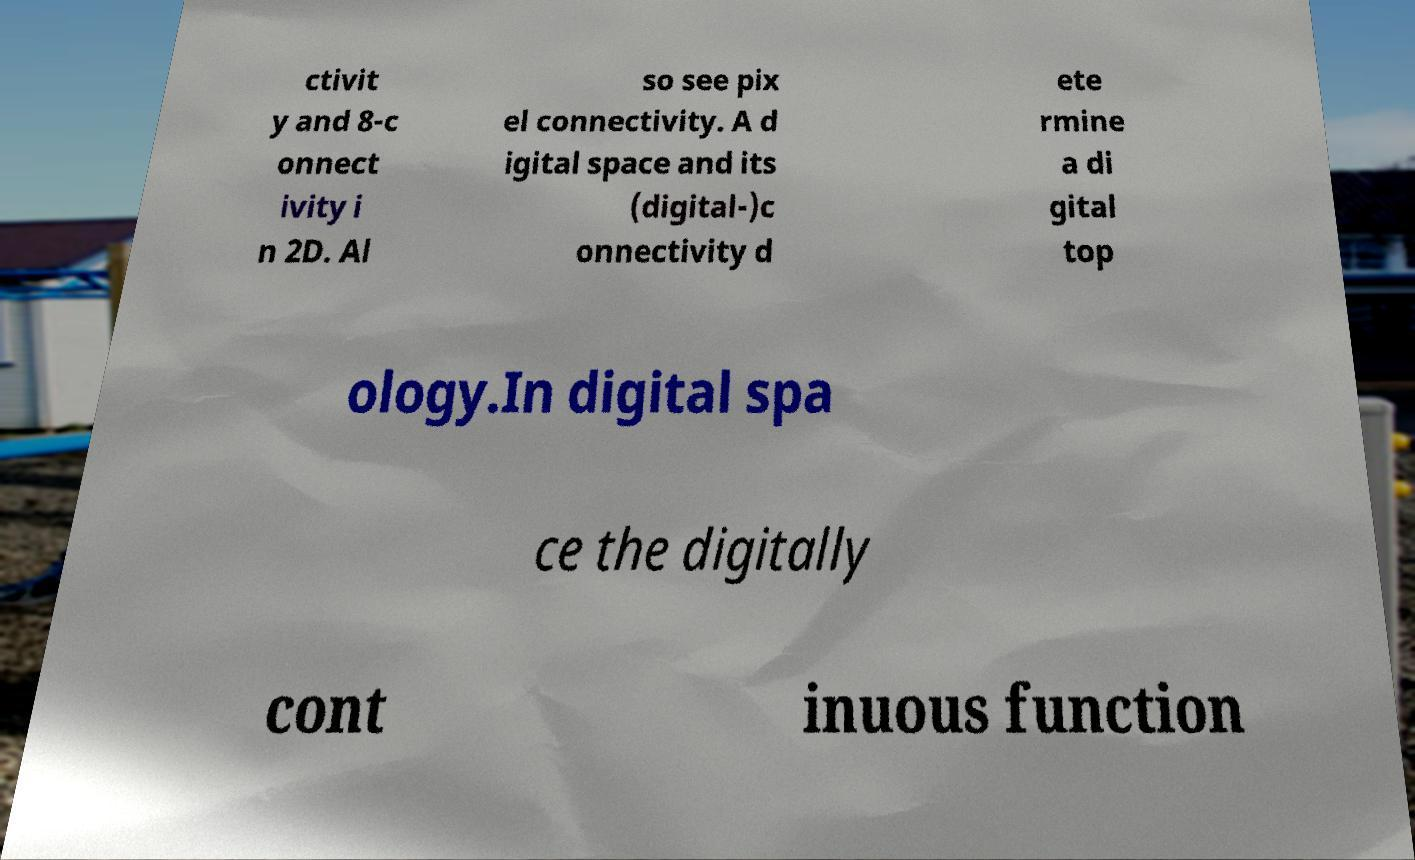What messages or text are displayed in this image? I need them in a readable, typed format. ctivit y and 8-c onnect ivity i n 2D. Al so see pix el connectivity. A d igital space and its (digital-)c onnectivity d ete rmine a di gital top ology.In digital spa ce the digitally cont inuous function 